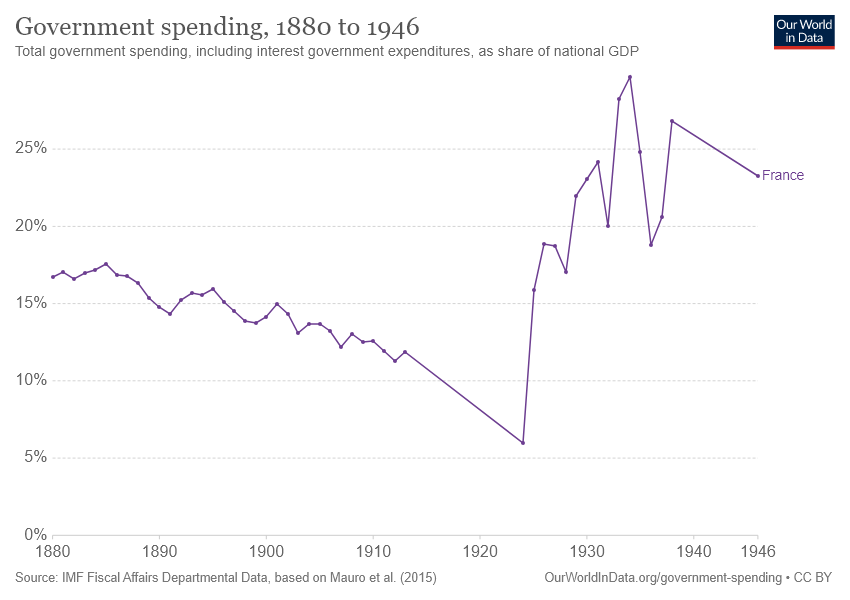Specify some key components in this picture. The government spending is at its minimum between the years 1920 and 1930. 